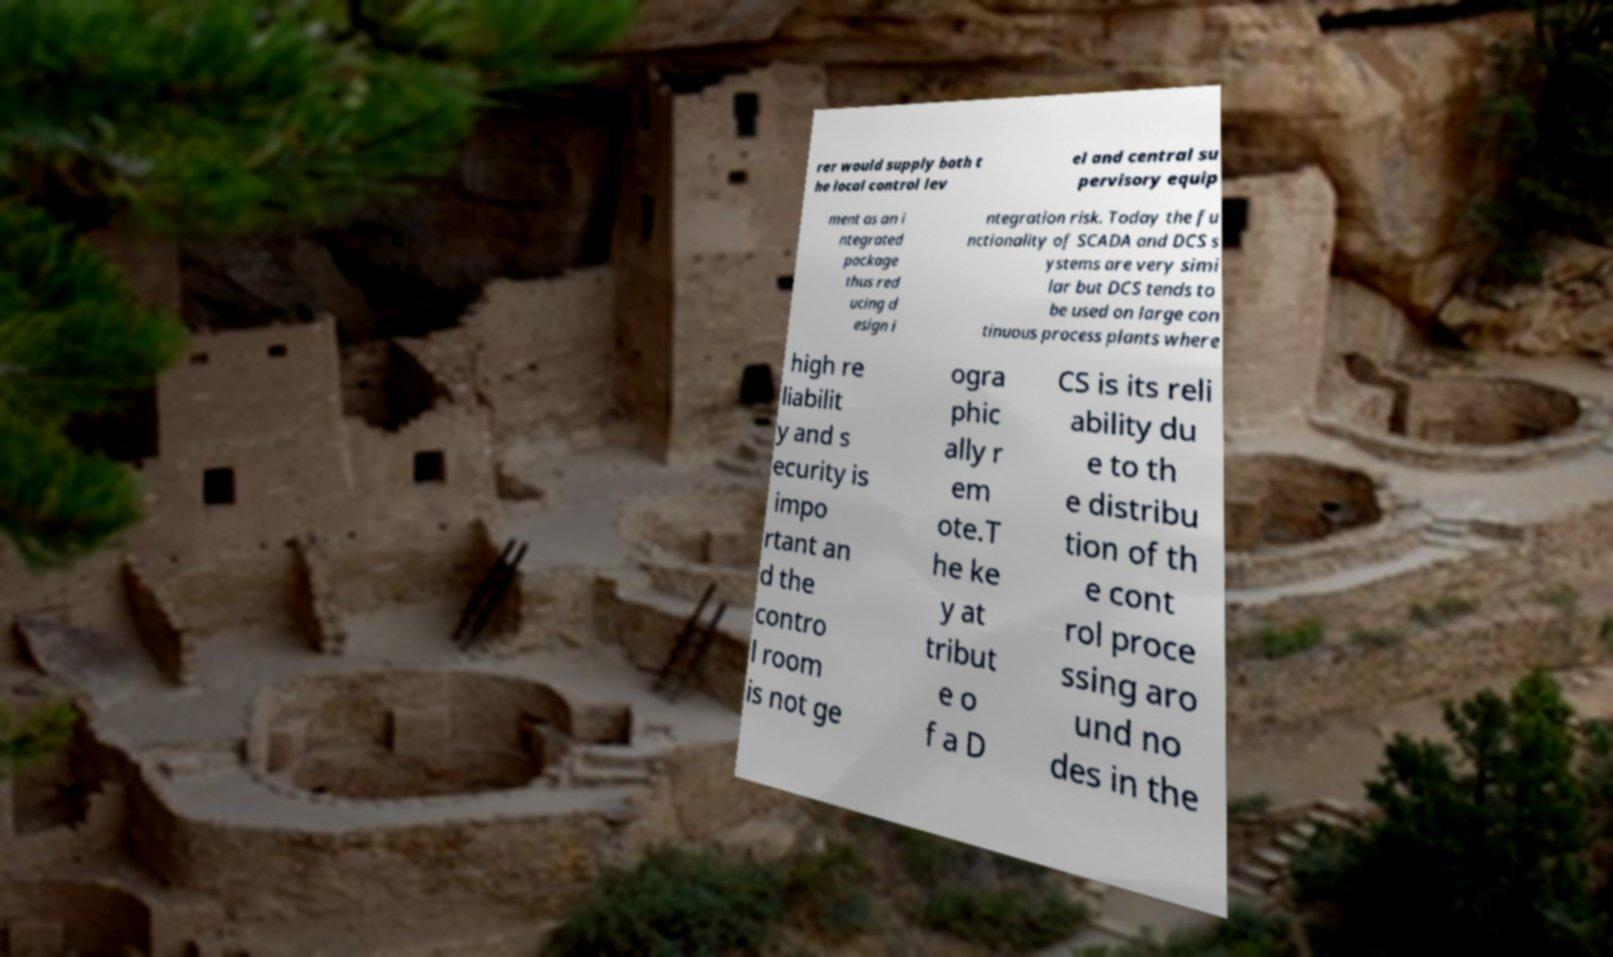For documentation purposes, I need the text within this image transcribed. Could you provide that? rer would supply both t he local control lev el and central su pervisory equip ment as an i ntegrated package thus red ucing d esign i ntegration risk. Today the fu nctionality of SCADA and DCS s ystems are very simi lar but DCS tends to be used on large con tinuous process plants where high re liabilit y and s ecurity is impo rtant an d the contro l room is not ge ogra phic ally r em ote.T he ke y at tribut e o f a D CS is its reli ability du e to th e distribu tion of th e cont rol proce ssing aro und no des in the 